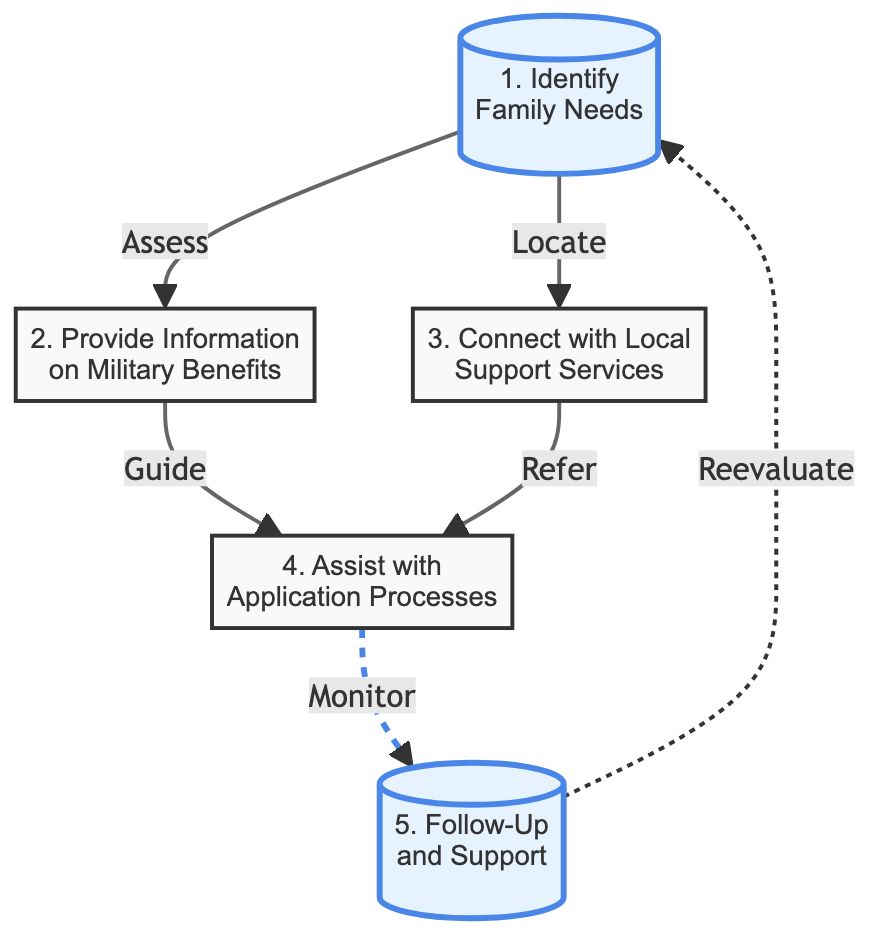What is the first step in the process? The first step is labeled as "1. Identify Family Needs", which is the starting point of the flowchart and indicates the process begins by understanding the family's specific assistance requirements.
Answer: 1. Identify Family Needs How many total steps are represented in the diagram? The diagram features five steps represented as nodes, each describing a part of the process for assisting families in accessing military benefits and resources.
Answer: 5 Which step follows "Provide Information on Military Benefits"? The diagram shows that after "Provide Information on Military Benefits," the next step is "Assist with Application Processes," indicating that providing information leads directly to helping families with applications.
Answer: Assist with Application Processes What action is taken after "Assist with Application Processes"? After completing "Assist with Application Processes," the flowchart indicates that the next action is "Follow-Up and Support," which implies ongoing support after helping families apply for benefits.
Answer: Follow-Up and Support How does "Connect with Local Support Services" relate to "Assist with Application Processes"? The diagram illustrates that "Connect with Local Support Services" refers families into the "Assist with Application Processes," indicating that local support services play a role in helping families navigate applications.
Answer: Refer What does the dashed line from "Follow-Up and Support" indicate? The dashed line from "Follow-Up and Support" back to "Identify Family Needs" suggests a reevaluation process, which indicates that follow-up may lead to identifying new or ongoing needs for assistance.
Answer: Reevaluation What is the last step in the process according to the diagram? The last step in the process is labeled "5. Follow-Up and Support," illustrating that ongoing support is crucial after initial assistance has been provided to families.
Answer: 5. Follow-Up and Support Which step directly links to "Local Support Services"? In the diagram, the step "3. Connect with Local Support Services" directly relates to linking families with community assistance resources, showing its role in the flowchart.
Answer: Connect with Local Support Services 